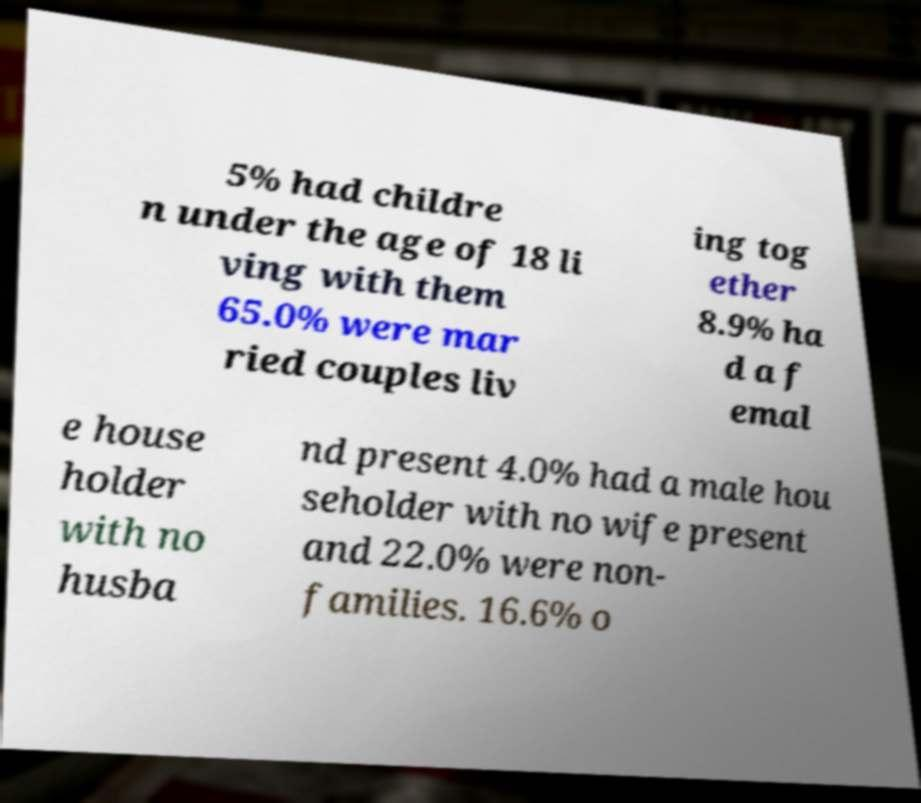Can you accurately transcribe the text from the provided image for me? 5% had childre n under the age of 18 li ving with them 65.0% were mar ried couples liv ing tog ether 8.9% ha d a f emal e house holder with no husba nd present 4.0% had a male hou seholder with no wife present and 22.0% were non- families. 16.6% o 